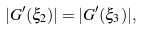Convert formula to latex. <formula><loc_0><loc_0><loc_500><loc_500>| G ^ { \prime } ( \xi _ { 2 } ) | = | G ^ { \prime } ( \xi _ { 3 } ) | ,</formula> 